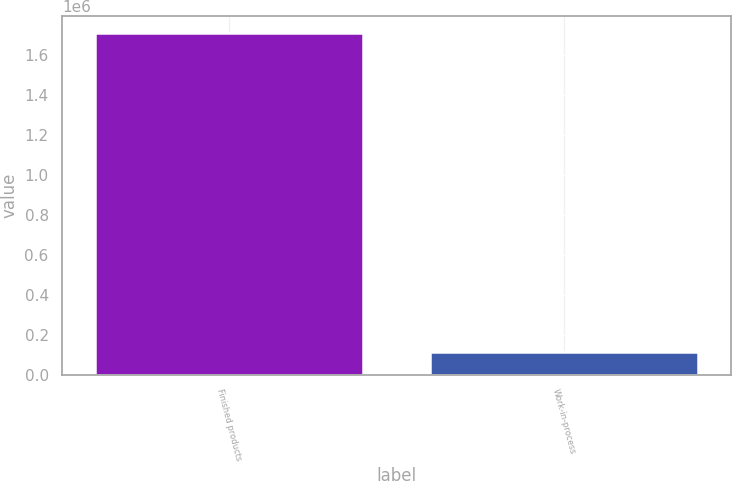Convert chart. <chart><loc_0><loc_0><loc_500><loc_500><bar_chart><fcel>Finished products<fcel>Work-in-process<nl><fcel>1.71126e+06<fcel>114356<nl></chart> 